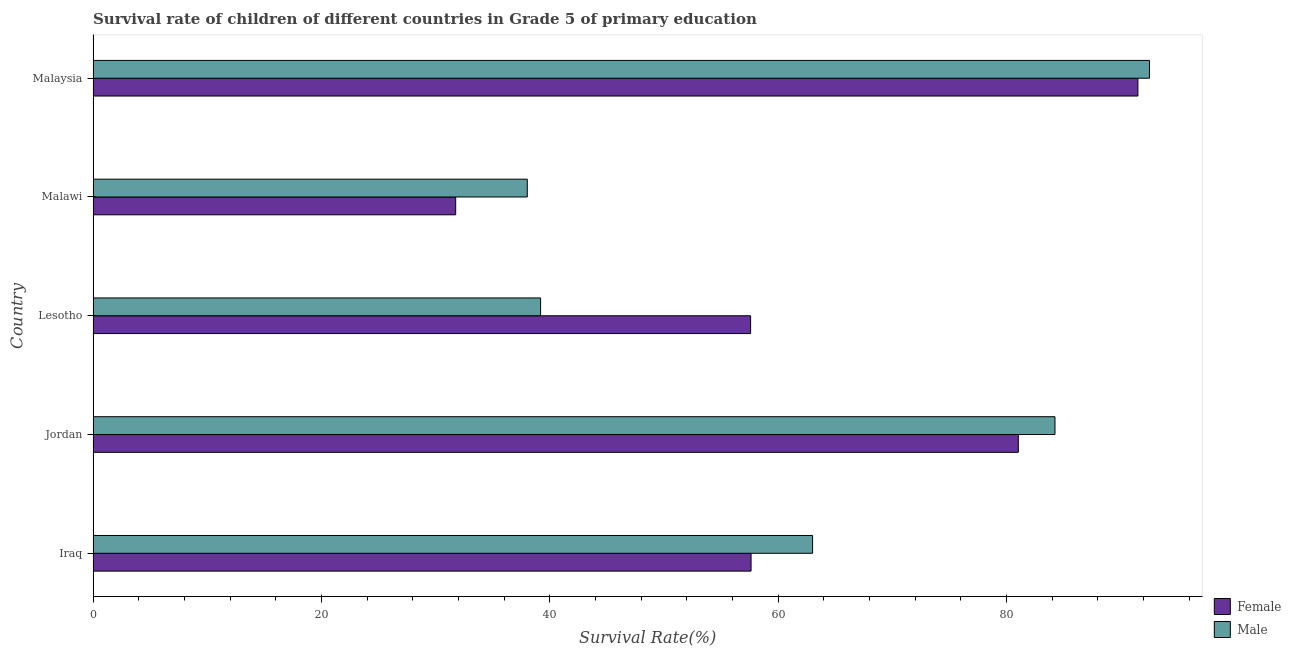How many bars are there on the 2nd tick from the top?
Ensure brevity in your answer.  2. What is the label of the 2nd group of bars from the top?
Provide a short and direct response. Malawi. In how many cases, is the number of bars for a given country not equal to the number of legend labels?
Provide a short and direct response. 0. What is the survival rate of male students in primary education in Malawi?
Offer a terse response. 38.03. Across all countries, what is the maximum survival rate of female students in primary education?
Provide a short and direct response. 91.51. Across all countries, what is the minimum survival rate of male students in primary education?
Ensure brevity in your answer.  38.03. In which country was the survival rate of female students in primary education maximum?
Provide a succinct answer. Malaysia. In which country was the survival rate of female students in primary education minimum?
Offer a very short reply. Malawi. What is the total survival rate of female students in primary education in the graph?
Your answer should be compact. 319.51. What is the difference between the survival rate of female students in primary education in Iraq and that in Malaysia?
Your response must be concise. -33.88. What is the difference between the survival rate of female students in primary education in Lesotho and the survival rate of male students in primary education in Iraq?
Your answer should be very brief. -5.43. What is the average survival rate of male students in primary education per country?
Ensure brevity in your answer.  63.4. What is the difference between the survival rate of male students in primary education and survival rate of female students in primary education in Malawi?
Keep it short and to the point. 6.27. In how many countries, is the survival rate of female students in primary education greater than 60 %?
Offer a terse response. 2. What is the ratio of the survival rate of female students in primary education in Lesotho to that in Malawi?
Make the answer very short. 1.81. Is the survival rate of male students in primary education in Lesotho less than that in Malawi?
Make the answer very short. No. Is the difference between the survival rate of male students in primary education in Iraq and Malawi greater than the difference between the survival rate of female students in primary education in Iraq and Malawi?
Ensure brevity in your answer.  No. What is the difference between the highest and the second highest survival rate of female students in primary education?
Make the answer very short. 10.47. What is the difference between the highest and the lowest survival rate of female students in primary education?
Provide a short and direct response. 59.75. Is the sum of the survival rate of female students in primary education in Iraq and Malawi greater than the maximum survival rate of male students in primary education across all countries?
Provide a succinct answer. No. What does the 2nd bar from the top in Iraq represents?
Ensure brevity in your answer.  Female. How many bars are there?
Your answer should be compact. 10. Are all the bars in the graph horizontal?
Offer a terse response. Yes. Are the values on the major ticks of X-axis written in scientific E-notation?
Ensure brevity in your answer.  No. Where does the legend appear in the graph?
Ensure brevity in your answer.  Bottom right. How are the legend labels stacked?
Make the answer very short. Vertical. What is the title of the graph?
Provide a short and direct response. Survival rate of children of different countries in Grade 5 of primary education. Does "Depositors" appear as one of the legend labels in the graph?
Ensure brevity in your answer.  No. What is the label or title of the X-axis?
Ensure brevity in your answer.  Survival Rate(%). What is the Survival Rate(%) in Female in Iraq?
Make the answer very short. 57.63. What is the Survival Rate(%) of Male in Iraq?
Offer a terse response. 63.01. What is the Survival Rate(%) of Female in Jordan?
Your response must be concise. 81.03. What is the Survival Rate(%) in Male in Jordan?
Your response must be concise. 84.24. What is the Survival Rate(%) in Female in Lesotho?
Offer a terse response. 57.59. What is the Survival Rate(%) of Male in Lesotho?
Your answer should be very brief. 39.19. What is the Survival Rate(%) of Female in Malawi?
Make the answer very short. 31.76. What is the Survival Rate(%) in Male in Malawi?
Offer a terse response. 38.03. What is the Survival Rate(%) of Female in Malaysia?
Your answer should be compact. 91.51. What is the Survival Rate(%) of Male in Malaysia?
Provide a succinct answer. 92.52. Across all countries, what is the maximum Survival Rate(%) in Female?
Keep it short and to the point. 91.51. Across all countries, what is the maximum Survival Rate(%) of Male?
Keep it short and to the point. 92.52. Across all countries, what is the minimum Survival Rate(%) in Female?
Provide a short and direct response. 31.76. Across all countries, what is the minimum Survival Rate(%) in Male?
Provide a short and direct response. 38.03. What is the total Survival Rate(%) in Female in the graph?
Offer a terse response. 319.51. What is the total Survival Rate(%) of Male in the graph?
Give a very brief answer. 317. What is the difference between the Survival Rate(%) of Female in Iraq and that in Jordan?
Ensure brevity in your answer.  -23.41. What is the difference between the Survival Rate(%) of Male in Iraq and that in Jordan?
Make the answer very short. -21.23. What is the difference between the Survival Rate(%) in Female in Iraq and that in Lesotho?
Give a very brief answer. 0.04. What is the difference between the Survival Rate(%) in Male in Iraq and that in Lesotho?
Your answer should be compact. 23.82. What is the difference between the Survival Rate(%) in Female in Iraq and that in Malawi?
Keep it short and to the point. 25.87. What is the difference between the Survival Rate(%) in Male in Iraq and that in Malawi?
Provide a succinct answer. 24.99. What is the difference between the Survival Rate(%) in Female in Iraq and that in Malaysia?
Offer a terse response. -33.88. What is the difference between the Survival Rate(%) in Male in Iraq and that in Malaysia?
Make the answer very short. -29.51. What is the difference between the Survival Rate(%) of Female in Jordan and that in Lesotho?
Offer a terse response. 23.45. What is the difference between the Survival Rate(%) in Male in Jordan and that in Lesotho?
Make the answer very short. 45.05. What is the difference between the Survival Rate(%) of Female in Jordan and that in Malawi?
Offer a very short reply. 49.28. What is the difference between the Survival Rate(%) in Male in Jordan and that in Malawi?
Your response must be concise. 46.22. What is the difference between the Survival Rate(%) of Female in Jordan and that in Malaysia?
Provide a short and direct response. -10.47. What is the difference between the Survival Rate(%) of Male in Jordan and that in Malaysia?
Provide a short and direct response. -8.28. What is the difference between the Survival Rate(%) of Female in Lesotho and that in Malawi?
Keep it short and to the point. 25.83. What is the difference between the Survival Rate(%) of Male in Lesotho and that in Malawi?
Your answer should be very brief. 1.16. What is the difference between the Survival Rate(%) in Female in Lesotho and that in Malaysia?
Your answer should be compact. -33.92. What is the difference between the Survival Rate(%) of Male in Lesotho and that in Malaysia?
Your answer should be compact. -53.33. What is the difference between the Survival Rate(%) in Female in Malawi and that in Malaysia?
Provide a succinct answer. -59.75. What is the difference between the Survival Rate(%) in Male in Malawi and that in Malaysia?
Give a very brief answer. -54.49. What is the difference between the Survival Rate(%) in Female in Iraq and the Survival Rate(%) in Male in Jordan?
Your response must be concise. -26.62. What is the difference between the Survival Rate(%) of Female in Iraq and the Survival Rate(%) of Male in Lesotho?
Offer a terse response. 18.43. What is the difference between the Survival Rate(%) of Female in Iraq and the Survival Rate(%) of Male in Malawi?
Provide a short and direct response. 19.6. What is the difference between the Survival Rate(%) of Female in Iraq and the Survival Rate(%) of Male in Malaysia?
Give a very brief answer. -34.89. What is the difference between the Survival Rate(%) in Female in Jordan and the Survival Rate(%) in Male in Lesotho?
Your response must be concise. 41.84. What is the difference between the Survival Rate(%) of Female in Jordan and the Survival Rate(%) of Male in Malawi?
Your response must be concise. 43.01. What is the difference between the Survival Rate(%) in Female in Jordan and the Survival Rate(%) in Male in Malaysia?
Keep it short and to the point. -11.49. What is the difference between the Survival Rate(%) of Female in Lesotho and the Survival Rate(%) of Male in Malawi?
Make the answer very short. 19.56. What is the difference between the Survival Rate(%) in Female in Lesotho and the Survival Rate(%) in Male in Malaysia?
Your answer should be very brief. -34.93. What is the difference between the Survival Rate(%) in Female in Malawi and the Survival Rate(%) in Male in Malaysia?
Your answer should be very brief. -60.76. What is the average Survival Rate(%) of Female per country?
Make the answer very short. 63.9. What is the average Survival Rate(%) in Male per country?
Make the answer very short. 63.4. What is the difference between the Survival Rate(%) in Female and Survival Rate(%) in Male in Iraq?
Your answer should be compact. -5.39. What is the difference between the Survival Rate(%) in Female and Survival Rate(%) in Male in Jordan?
Your answer should be very brief. -3.21. What is the difference between the Survival Rate(%) in Female and Survival Rate(%) in Male in Lesotho?
Provide a short and direct response. 18.39. What is the difference between the Survival Rate(%) in Female and Survival Rate(%) in Male in Malawi?
Offer a terse response. -6.27. What is the difference between the Survival Rate(%) in Female and Survival Rate(%) in Male in Malaysia?
Your response must be concise. -1.02. What is the ratio of the Survival Rate(%) of Female in Iraq to that in Jordan?
Offer a terse response. 0.71. What is the ratio of the Survival Rate(%) of Male in Iraq to that in Jordan?
Keep it short and to the point. 0.75. What is the ratio of the Survival Rate(%) in Male in Iraq to that in Lesotho?
Your answer should be very brief. 1.61. What is the ratio of the Survival Rate(%) of Female in Iraq to that in Malawi?
Give a very brief answer. 1.81. What is the ratio of the Survival Rate(%) in Male in Iraq to that in Malawi?
Provide a succinct answer. 1.66. What is the ratio of the Survival Rate(%) in Female in Iraq to that in Malaysia?
Provide a short and direct response. 0.63. What is the ratio of the Survival Rate(%) of Male in Iraq to that in Malaysia?
Your answer should be compact. 0.68. What is the ratio of the Survival Rate(%) in Female in Jordan to that in Lesotho?
Make the answer very short. 1.41. What is the ratio of the Survival Rate(%) in Male in Jordan to that in Lesotho?
Give a very brief answer. 2.15. What is the ratio of the Survival Rate(%) of Female in Jordan to that in Malawi?
Ensure brevity in your answer.  2.55. What is the ratio of the Survival Rate(%) of Male in Jordan to that in Malawi?
Your answer should be compact. 2.22. What is the ratio of the Survival Rate(%) of Female in Jordan to that in Malaysia?
Offer a very short reply. 0.89. What is the ratio of the Survival Rate(%) of Male in Jordan to that in Malaysia?
Your answer should be compact. 0.91. What is the ratio of the Survival Rate(%) of Female in Lesotho to that in Malawi?
Keep it short and to the point. 1.81. What is the ratio of the Survival Rate(%) of Male in Lesotho to that in Malawi?
Give a very brief answer. 1.03. What is the ratio of the Survival Rate(%) in Female in Lesotho to that in Malaysia?
Keep it short and to the point. 0.63. What is the ratio of the Survival Rate(%) in Male in Lesotho to that in Malaysia?
Your answer should be compact. 0.42. What is the ratio of the Survival Rate(%) of Female in Malawi to that in Malaysia?
Your answer should be compact. 0.35. What is the ratio of the Survival Rate(%) of Male in Malawi to that in Malaysia?
Offer a very short reply. 0.41. What is the difference between the highest and the second highest Survival Rate(%) in Female?
Ensure brevity in your answer.  10.47. What is the difference between the highest and the second highest Survival Rate(%) in Male?
Give a very brief answer. 8.28. What is the difference between the highest and the lowest Survival Rate(%) in Female?
Offer a terse response. 59.75. What is the difference between the highest and the lowest Survival Rate(%) of Male?
Provide a short and direct response. 54.49. 